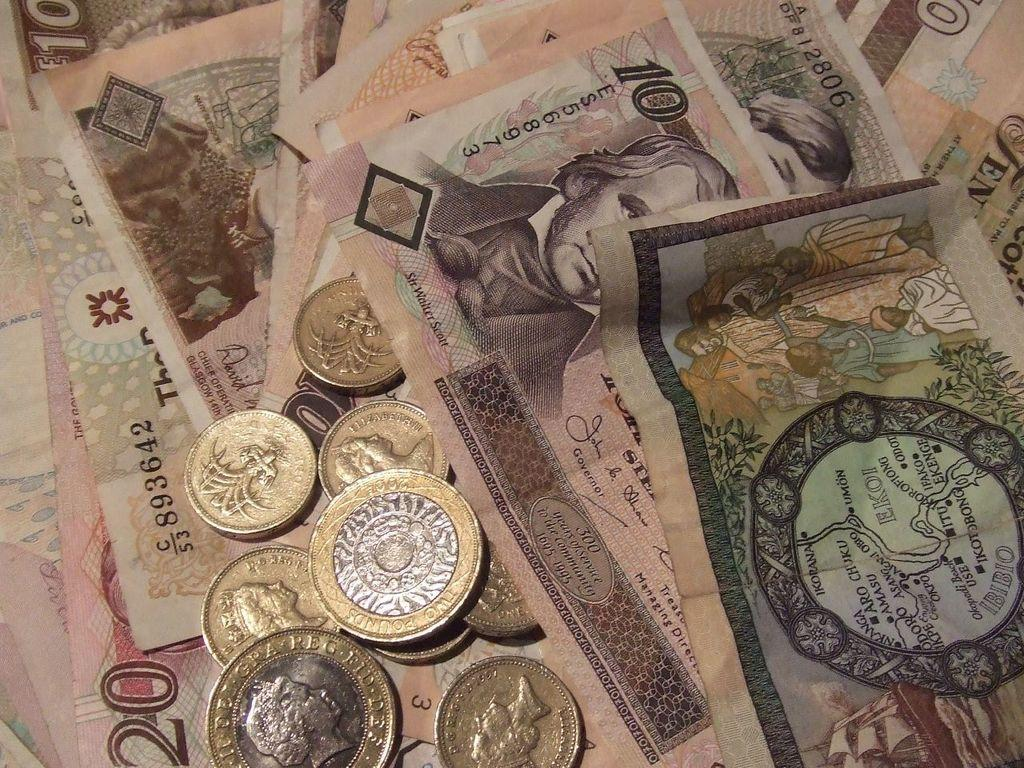<image>
Write a terse but informative summary of the picture. several pieces of money are laying here, including some 10 bills 